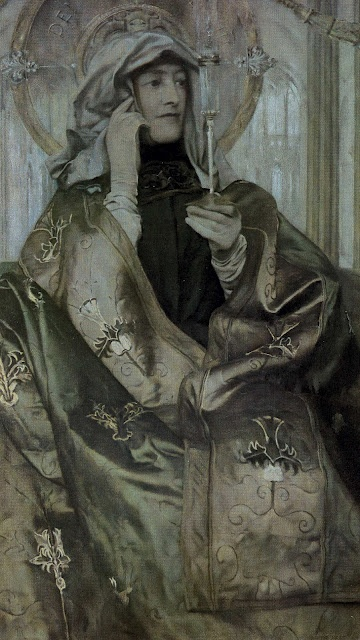What era do you think this woman belongs to, and what clues lead you to this conclusion? The woman appears to belong to the medieval era. This conclusion is drawn from several visual clues, such as her attire and headdress. The long, flowing robe adorned with intricate gold embroidery and the large headdress with a veil are characteristic of medieval fashion. Additionally, the style of the portrait, focusing on realism and detailed textures, suggests it may be inspired by medieval artwork, which often depicted figures in a composed and serene manner. 